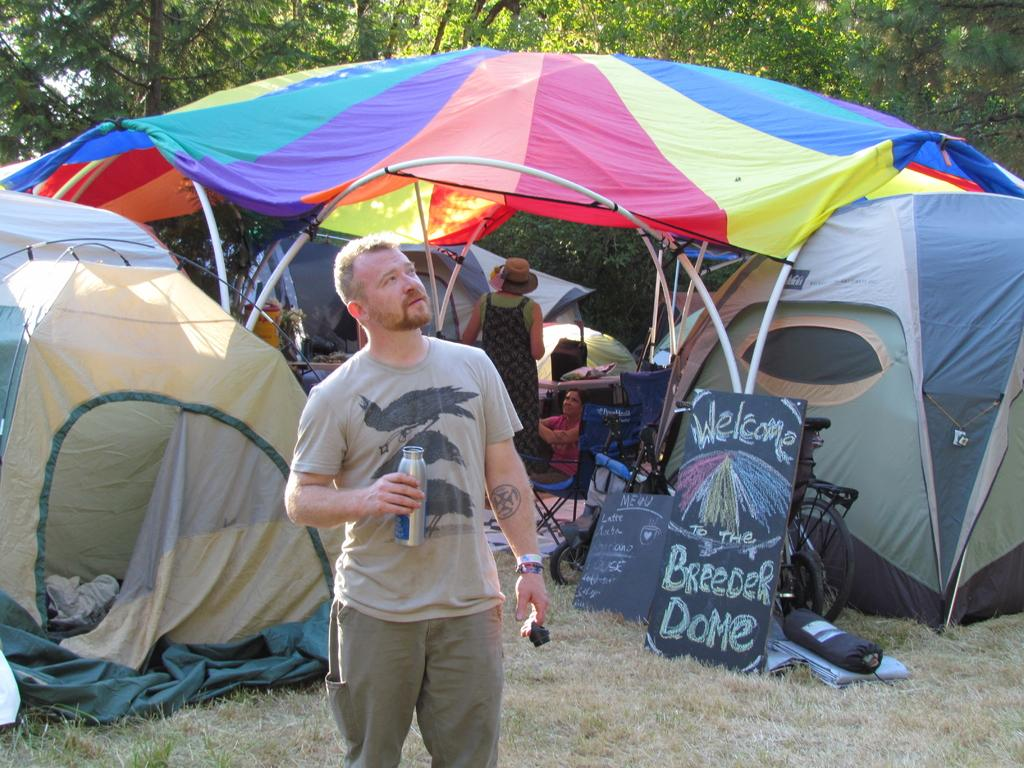What is the person holding in the image? The person is holding a bottle in the image. What can be seen in the background of the image? There are tents in the background of the image. Can you describe the colorful cover visible in the image? Yes, there is a colorful cover visible in the image. What type of vehicles are present in the image? Bicycles are present in the image. What type of writing surface is visible in the image? Blackboards are visible in the image. What type of seating is present in the image? Chairs are present in the image. What type of natural environment is visible in the image? Trees and grass are visible in the image. What objects can be seen on the ground in the image? There are objects on the ground in the image. What type of cake is being served at the decision-making meeting in the image? There is no cake or decision-making meeting present in the image. How does the person's haircut reflect their decision-making process in the image? There is no haircut or decision-making process visible in the image. 